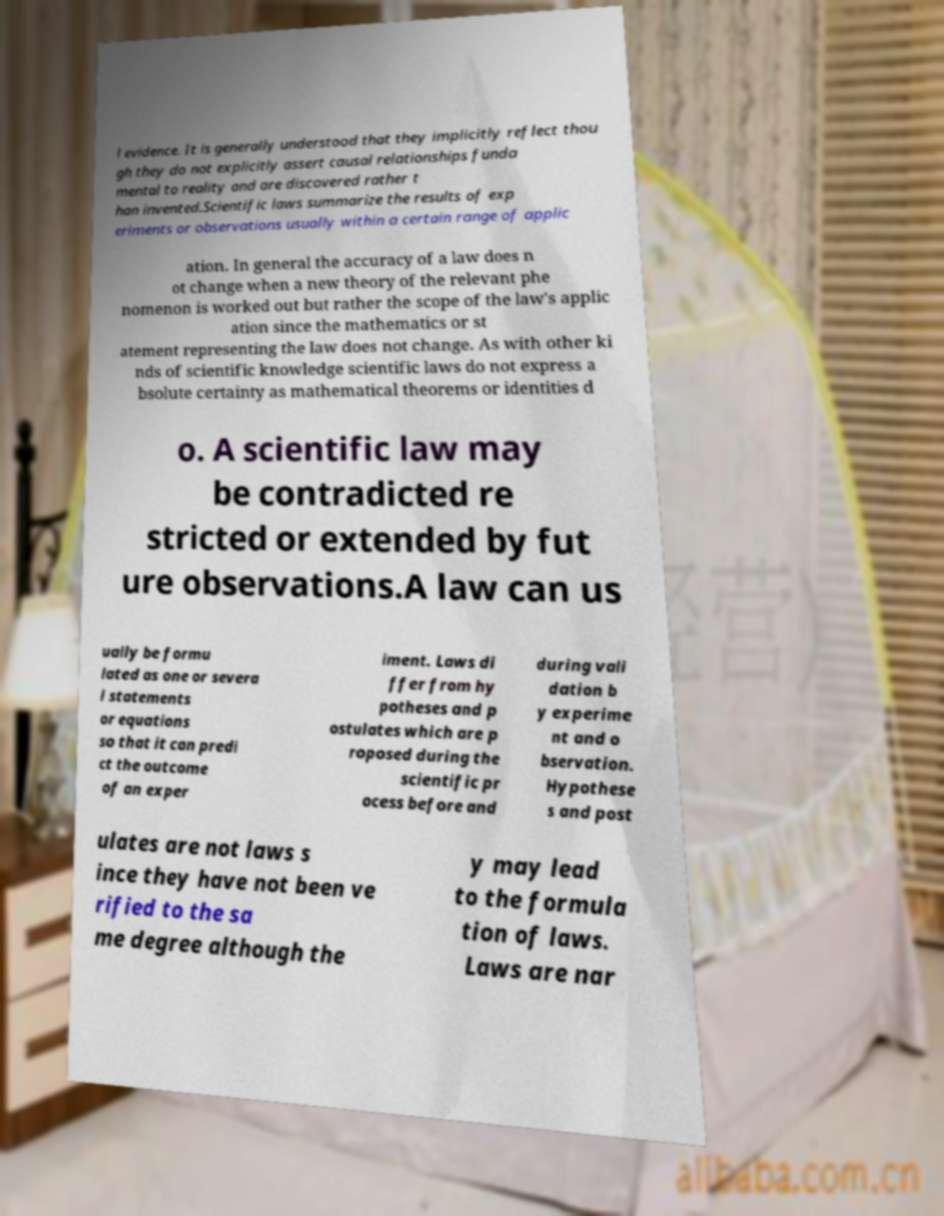Please read and relay the text visible in this image. What does it say? l evidence. It is generally understood that they implicitly reflect thou gh they do not explicitly assert causal relationships funda mental to reality and are discovered rather t han invented.Scientific laws summarize the results of exp eriments or observations usually within a certain range of applic ation. In general the accuracy of a law does n ot change when a new theory of the relevant phe nomenon is worked out but rather the scope of the law's applic ation since the mathematics or st atement representing the law does not change. As with other ki nds of scientific knowledge scientific laws do not express a bsolute certainty as mathematical theorems or identities d o. A scientific law may be contradicted re stricted or extended by fut ure observations.A law can us ually be formu lated as one or severa l statements or equations so that it can predi ct the outcome of an exper iment. Laws di ffer from hy potheses and p ostulates which are p roposed during the scientific pr ocess before and during vali dation b y experime nt and o bservation. Hypothese s and post ulates are not laws s ince they have not been ve rified to the sa me degree although the y may lead to the formula tion of laws. Laws are nar 